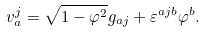Convert formula to latex. <formula><loc_0><loc_0><loc_500><loc_500>v _ { a } ^ { j } = \sqrt { 1 - \varphi ^ { 2 } } g _ { a j } + \varepsilon ^ { a j b } \varphi ^ { b } .</formula> 